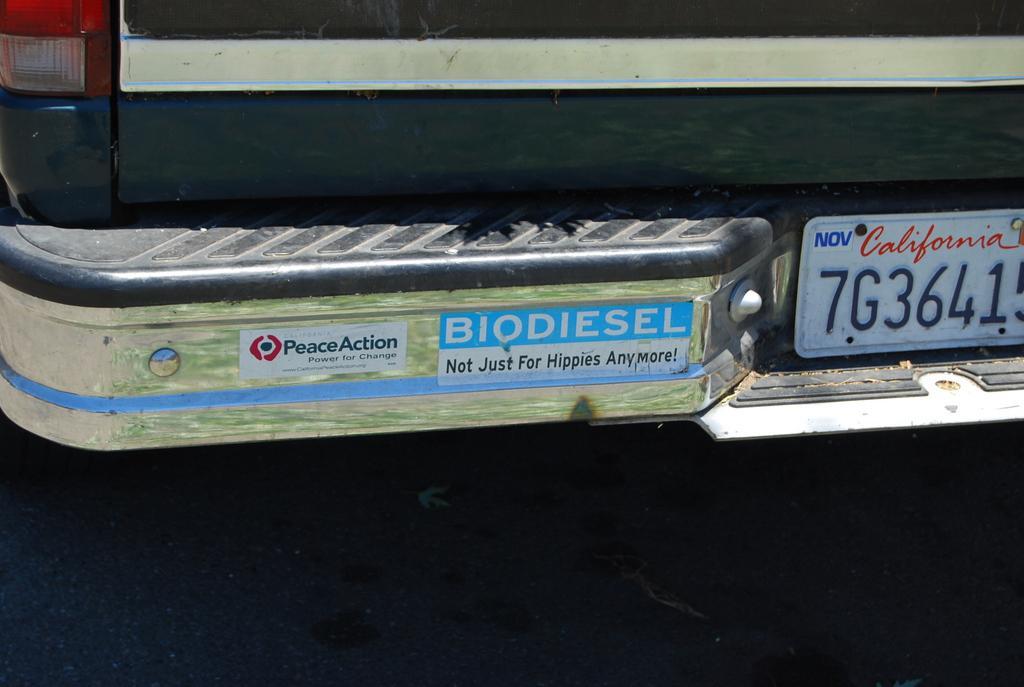What state issued the license plate?
Offer a terse response. California. What is the line under biodiesel?
Offer a terse response. Not just for hippies anymore. 